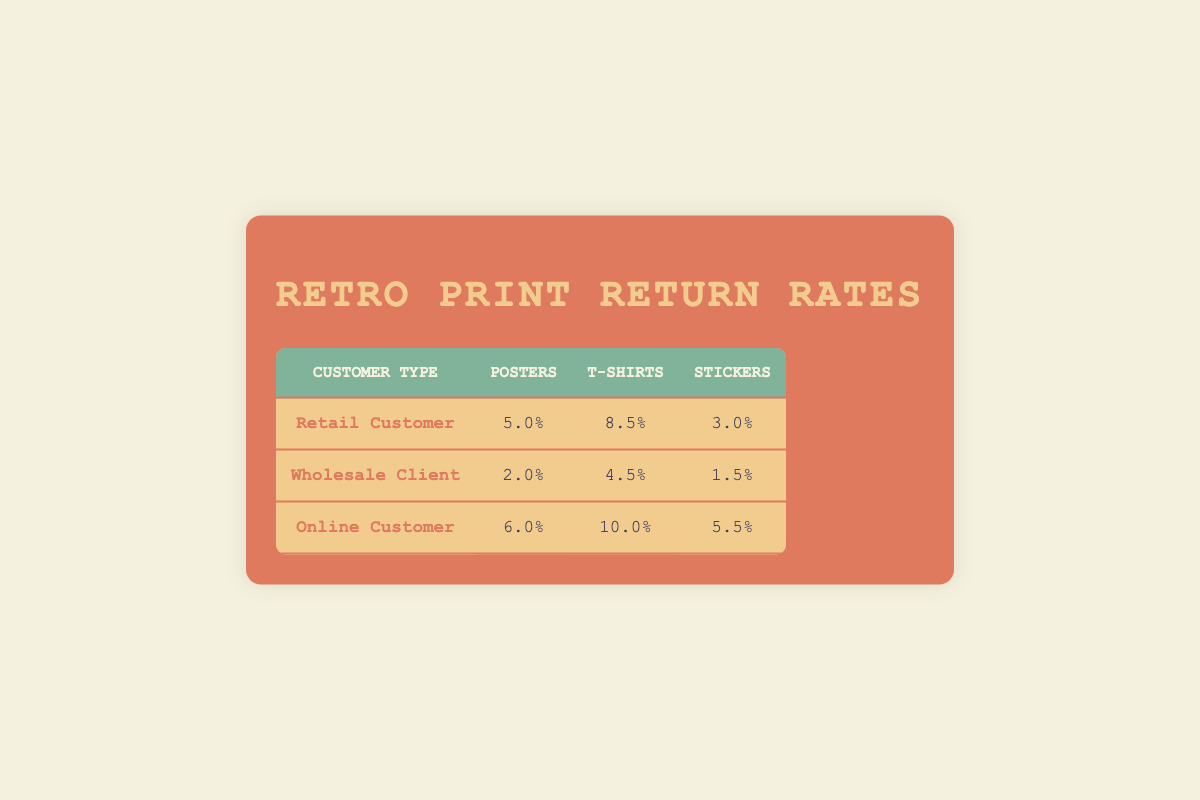What is the return rate for Posters sold to Retail Customers? The table indicates that the return rate for Posters under the category of Retail Customers is 5.0%.
Answer: 5.0% Which customer type has the highest return rate for T-shirts? Looking at the return rates for T-shirts, the Online Customer has the highest rate at 10.0%.
Answer: Online Customer What is the return rate for Stickers sold to Wholesale Clients? The table shows that the return rate for Stickers for Wholesale Clients is 1.5%.
Answer: 1.5% What is the average return rate for Posters among all customer types? To find the average return rate for Posters, sum the return rates (5.0 + 2.0 + 6.0 = 13.0) and divide by the number of customer types (3). The average return rate is 13.0 / 3 = 4.33%.
Answer: 4.33% Do Retail Customers have a higher return rate for Stickers compared to Wholesale Clients? The return rate for Stickers for Retail Customers is 3.0%, while for Wholesale Clients it is 1.5%. Since 3.0% is greater than 1.5%, the statement is true.
Answer: Yes What is the difference in return rates for T-shirts between Online Customers and Wholesale Clients? The return rate for T-shirts for Online Customers is 10.0% and for Wholesale Clients is 4.5%. Subtracting these gives: 10.0% - 4.5% = 5.5%.
Answer: 5.5% Which product category has the lowest return rate for retail customers? Upon examining the return rates for Retail Customers, Stickers have the lowest return rate at 3.0% compared to Posters (5.0%) and T-shirts (8.5%).
Answer: Stickers What is the combined return rate for all products sold to Wholesale Clients? The return rates for Wholesale Clients are: Posters at 2.0%, T-shirts at 4.5%, and Stickers at 1.5%. The combined return rate is calculated as: 2.0% + 4.5% + 1.5% = 8.0%.
Answer: 8.0% Is it true that Online Customers have a lower return rate for Posters than Retail Customers? The return rate for Posters sold to Online Customers is 6.0%, while for Retail Customers it is 5.0%. Since 6.0% is greater than 5.0%, the statement is false.
Answer: No 